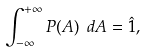Convert formula to latex. <formula><loc_0><loc_0><loc_500><loc_500>\int _ { - \infty } ^ { + \infty } P ( A ) \ d A = \hat { 1 } ,</formula> 